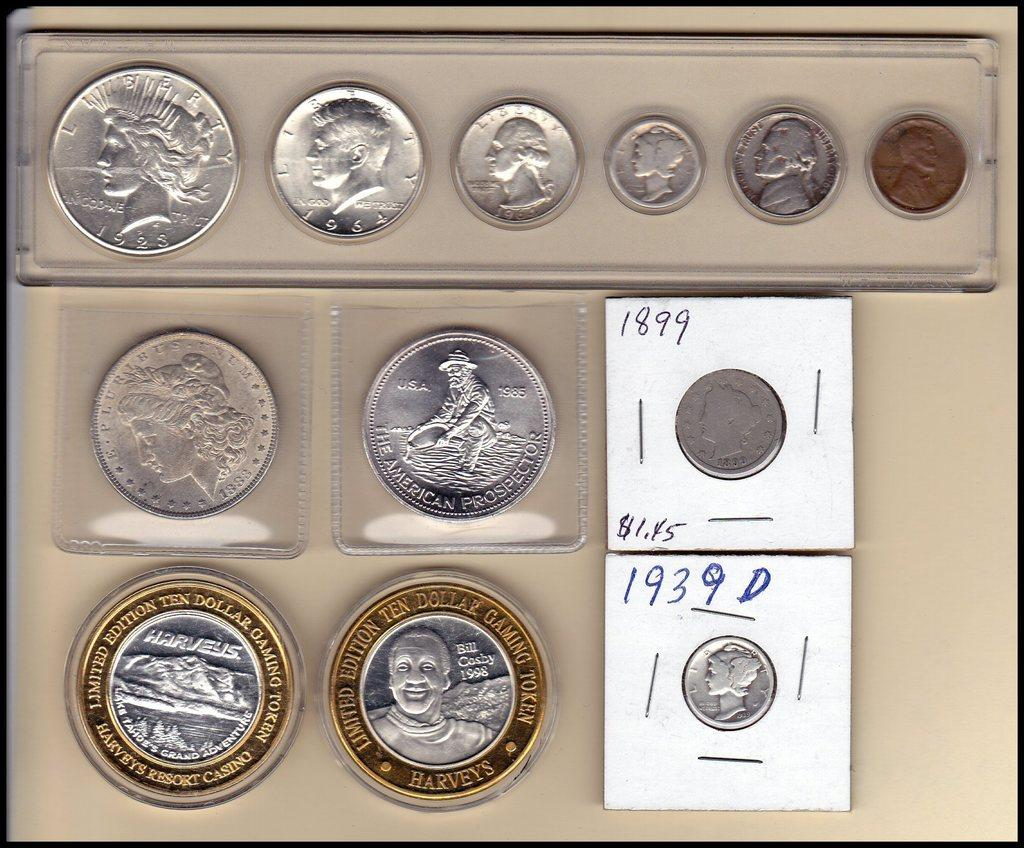<image>
Write a terse but informative summary of the picture. A coin collection that includes two limited edition ten dollar gaming tokens. 